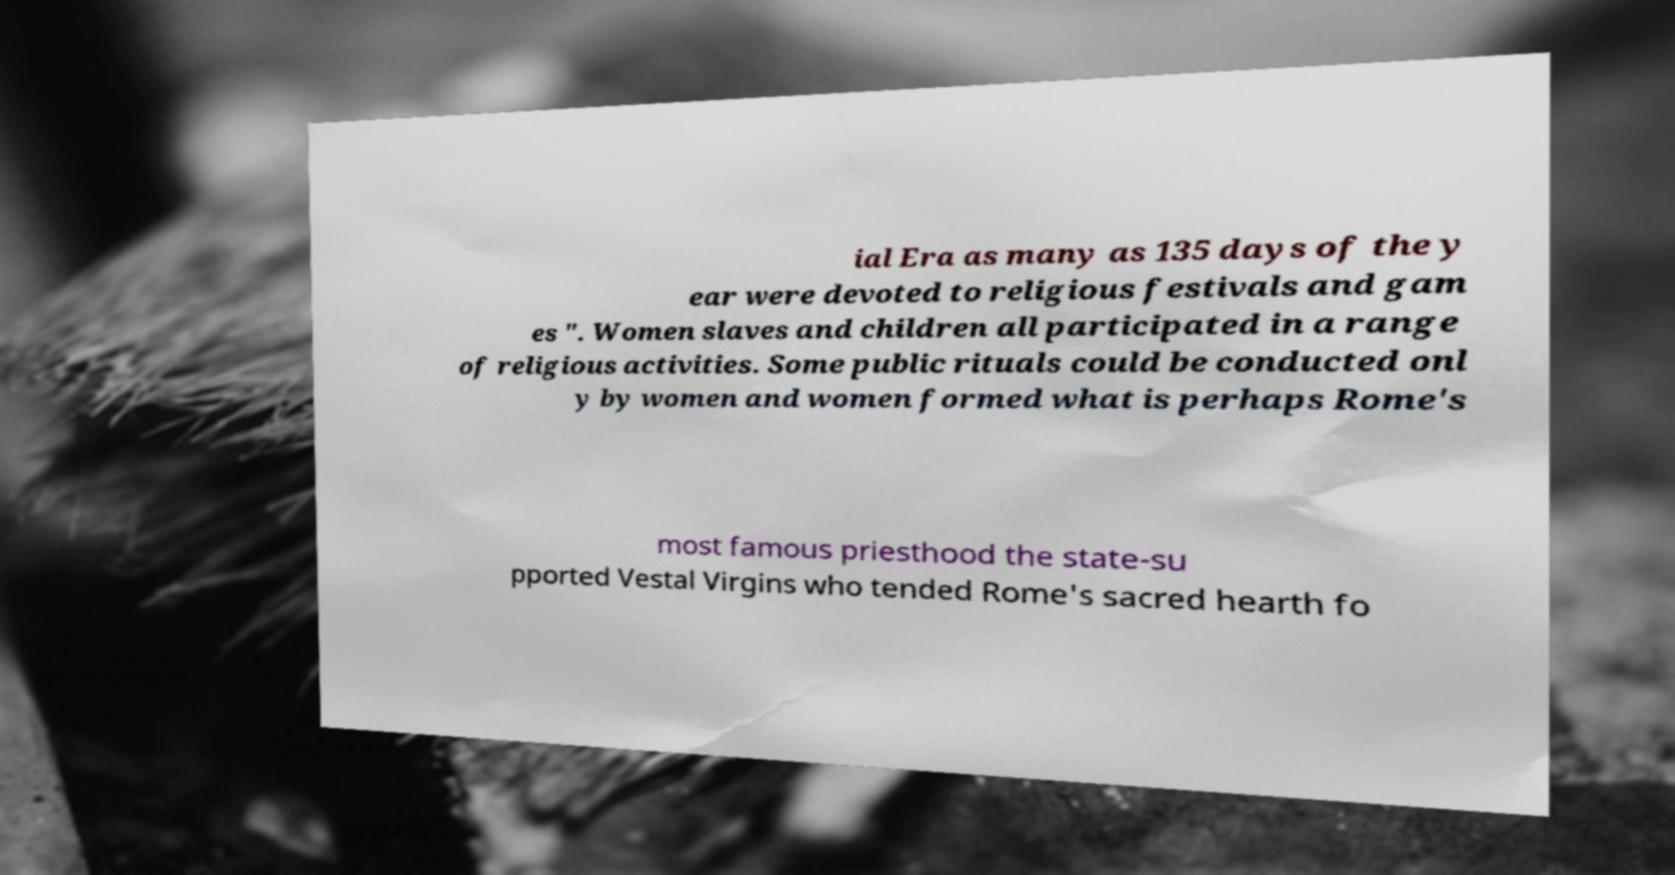What messages or text are displayed in this image? I need them in a readable, typed format. ial Era as many as 135 days of the y ear were devoted to religious festivals and gam es ". Women slaves and children all participated in a range of religious activities. Some public rituals could be conducted onl y by women and women formed what is perhaps Rome's most famous priesthood the state-su pported Vestal Virgins who tended Rome's sacred hearth fo 